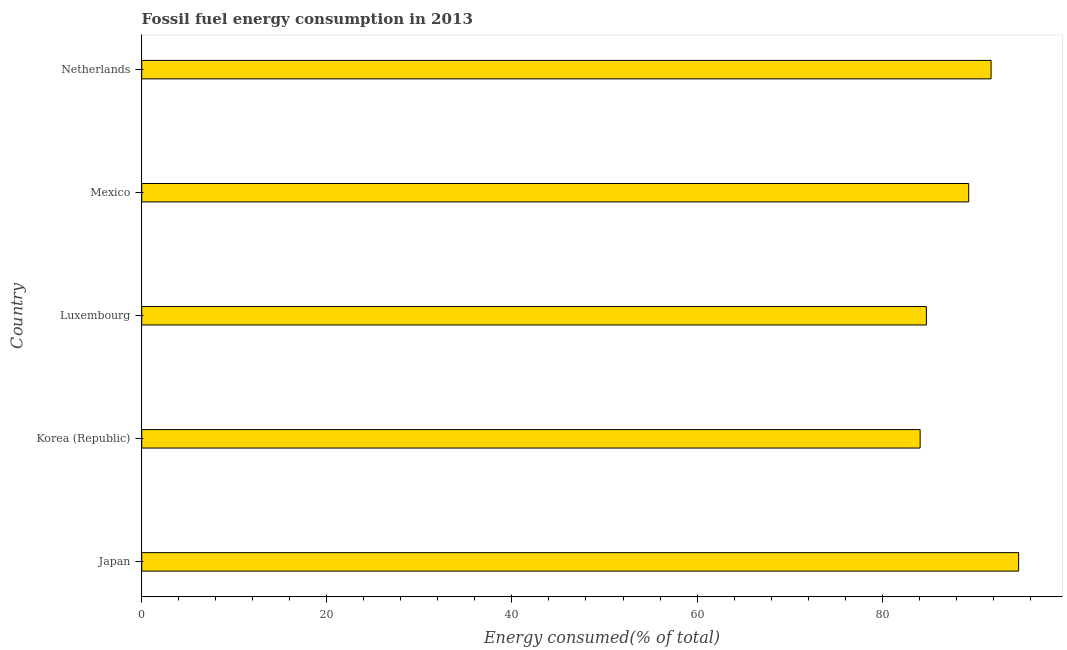Does the graph contain any zero values?
Make the answer very short. No. Does the graph contain grids?
Offer a terse response. No. What is the title of the graph?
Your answer should be very brief. Fossil fuel energy consumption in 2013. What is the label or title of the X-axis?
Provide a short and direct response. Energy consumed(% of total). What is the label or title of the Y-axis?
Keep it short and to the point. Country. What is the fossil fuel energy consumption in Netherlands?
Give a very brief answer. 91.77. Across all countries, what is the maximum fossil fuel energy consumption?
Your response must be concise. 94.75. Across all countries, what is the minimum fossil fuel energy consumption?
Provide a succinct answer. 84.1. In which country was the fossil fuel energy consumption maximum?
Your response must be concise. Japan. What is the sum of the fossil fuel energy consumption?
Make the answer very short. 444.75. What is the difference between the fossil fuel energy consumption in Japan and Netherlands?
Offer a terse response. 2.98. What is the average fossil fuel energy consumption per country?
Provide a succinct answer. 88.95. What is the median fossil fuel energy consumption?
Offer a terse response. 89.35. What is the ratio of the fossil fuel energy consumption in Japan to that in Mexico?
Provide a succinct answer. 1.06. Is the difference between the fossil fuel energy consumption in Korea (Republic) and Mexico greater than the difference between any two countries?
Make the answer very short. No. What is the difference between the highest and the second highest fossil fuel energy consumption?
Keep it short and to the point. 2.98. What is the difference between the highest and the lowest fossil fuel energy consumption?
Make the answer very short. 10.64. How many bars are there?
Make the answer very short. 5. How many countries are there in the graph?
Your response must be concise. 5. What is the difference between two consecutive major ticks on the X-axis?
Offer a terse response. 20. What is the Energy consumed(% of total) in Japan?
Ensure brevity in your answer.  94.75. What is the Energy consumed(% of total) of Korea (Republic)?
Offer a terse response. 84.1. What is the Energy consumed(% of total) of Luxembourg?
Give a very brief answer. 84.78. What is the Energy consumed(% of total) of Mexico?
Give a very brief answer. 89.35. What is the Energy consumed(% of total) in Netherlands?
Offer a terse response. 91.77. What is the difference between the Energy consumed(% of total) in Japan and Korea (Republic)?
Keep it short and to the point. 10.64. What is the difference between the Energy consumed(% of total) in Japan and Luxembourg?
Provide a short and direct response. 9.97. What is the difference between the Energy consumed(% of total) in Japan and Mexico?
Offer a terse response. 5.4. What is the difference between the Energy consumed(% of total) in Japan and Netherlands?
Ensure brevity in your answer.  2.98. What is the difference between the Energy consumed(% of total) in Korea (Republic) and Luxembourg?
Provide a succinct answer. -0.68. What is the difference between the Energy consumed(% of total) in Korea (Republic) and Mexico?
Give a very brief answer. -5.25. What is the difference between the Energy consumed(% of total) in Korea (Republic) and Netherlands?
Your response must be concise. -7.67. What is the difference between the Energy consumed(% of total) in Luxembourg and Mexico?
Offer a terse response. -4.57. What is the difference between the Energy consumed(% of total) in Luxembourg and Netherlands?
Make the answer very short. -6.99. What is the difference between the Energy consumed(% of total) in Mexico and Netherlands?
Ensure brevity in your answer.  -2.42. What is the ratio of the Energy consumed(% of total) in Japan to that in Korea (Republic)?
Offer a terse response. 1.13. What is the ratio of the Energy consumed(% of total) in Japan to that in Luxembourg?
Offer a terse response. 1.12. What is the ratio of the Energy consumed(% of total) in Japan to that in Mexico?
Provide a succinct answer. 1.06. What is the ratio of the Energy consumed(% of total) in Japan to that in Netherlands?
Give a very brief answer. 1.03. What is the ratio of the Energy consumed(% of total) in Korea (Republic) to that in Luxembourg?
Keep it short and to the point. 0.99. What is the ratio of the Energy consumed(% of total) in Korea (Republic) to that in Mexico?
Offer a terse response. 0.94. What is the ratio of the Energy consumed(% of total) in Korea (Republic) to that in Netherlands?
Your response must be concise. 0.92. What is the ratio of the Energy consumed(% of total) in Luxembourg to that in Mexico?
Give a very brief answer. 0.95. What is the ratio of the Energy consumed(% of total) in Luxembourg to that in Netherlands?
Your answer should be very brief. 0.92. 